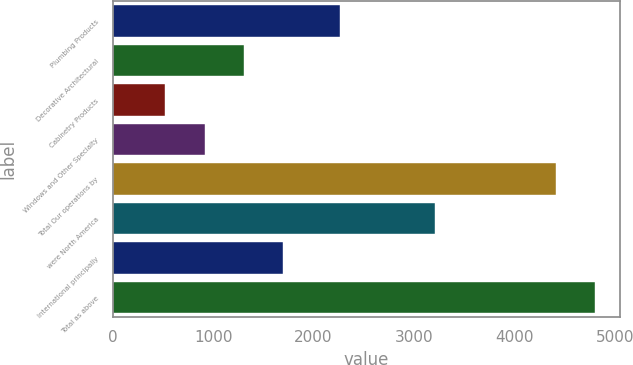Convert chart to OTSL. <chart><loc_0><loc_0><loc_500><loc_500><bar_chart><fcel>Plumbing Products<fcel>Decorative Architectural<fcel>Cabinetry Products<fcel>Windows and Other Specialty<fcel>Total Our operations by<fcel>were North America<fcel>International principally<fcel>Total as above<nl><fcel>2260<fcel>1302.8<fcel>524<fcel>913.4<fcel>4418<fcel>3211<fcel>1692.2<fcel>4807.4<nl></chart> 